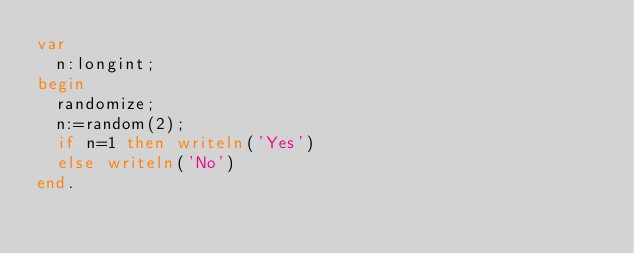<code> <loc_0><loc_0><loc_500><loc_500><_Pascal_>var 
  n:longint;
begin
  randomize;
  n:=random(2);
  if n=1 then writeln('Yes')
  else writeln('No')
end.</code> 